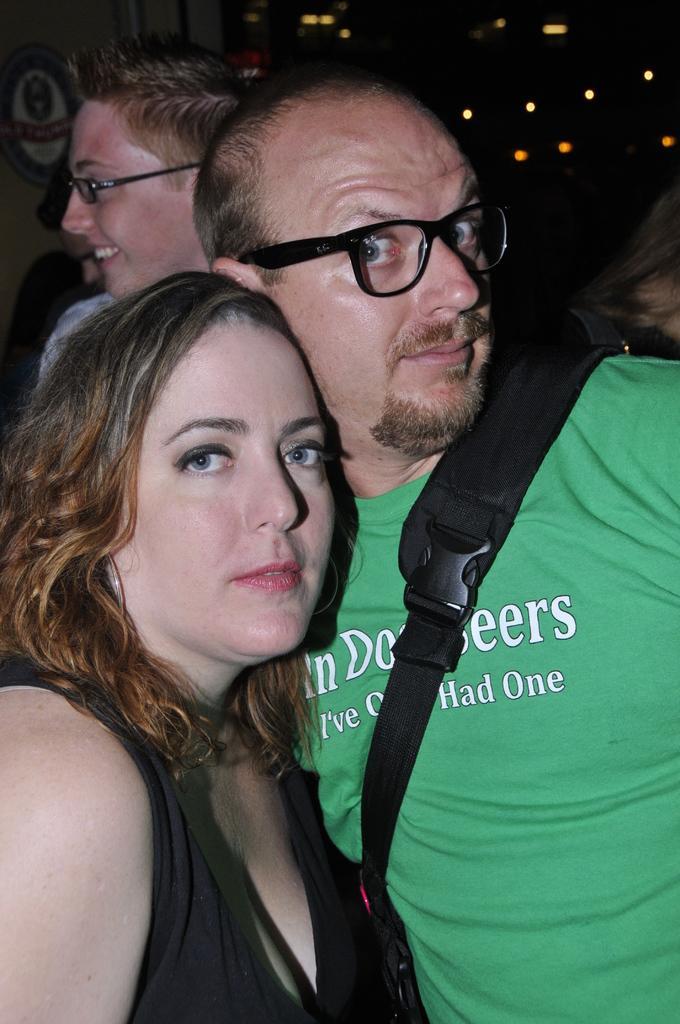In one or two sentences, can you explain what this image depicts? Here we can see a man and woman together and the man is carrying a bag on his shoulder,In the background the image is not clear but we can see few persons and lights. 